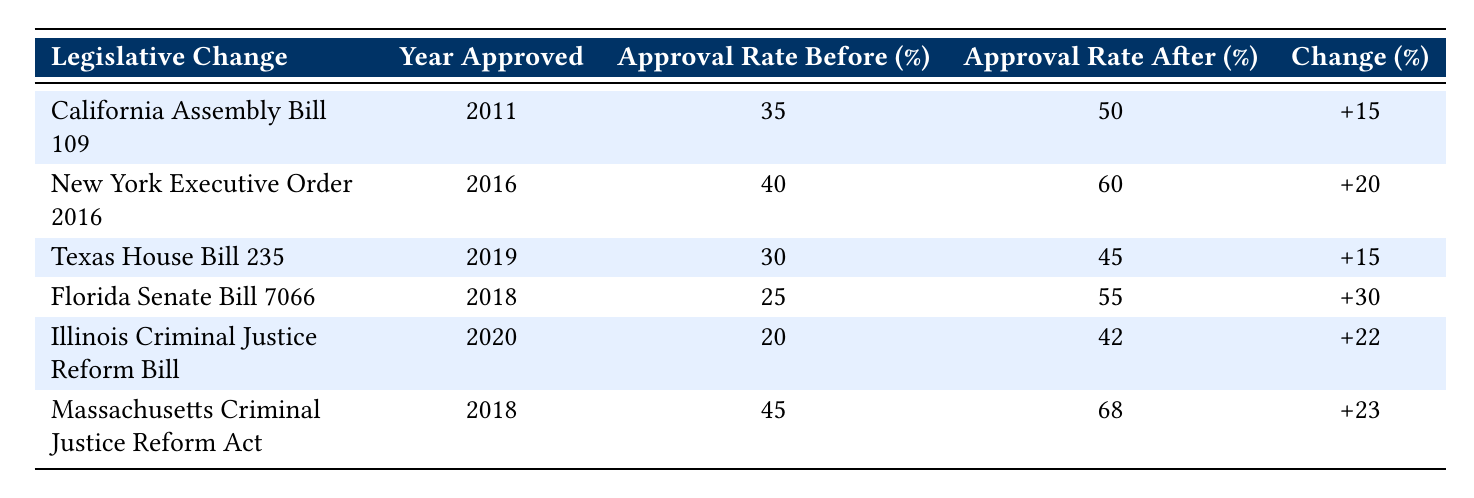What was the parole approval rate for Illinois Criminal Justice Reform Bill before the reform? The table lists the approval rate before the legislative change for Illinois Criminal Justice Reform Bill as 20%.
Answer: 20% What is the change in parole approval rate after New York Executive Order 2016? The table shows that the parole approval rate after the reform is 60% and before it was 40%, so the change is calculated by subtracting 40 from 60, resulting in a change of 20%.
Answer: +20% Which legislative change had the highest approval rate after its implementation? The table lists the approval rates after implementation, with Massachusetts Criminal Justice Reform Act at 68%, which is the highest compared to other listed changes.
Answer: Massachusetts Criminal Justice Reform Act How many legislative changes resulted in a parole approval rate increase of more than 20%? By examining the table, the changes greater than 20% are New York Executive Order 2016 (+20), Illinois Criminal Justice Reform Bill (+22), Florida Senate Bill 7066 (+30), and Massachusetts Criminal Justice Reform Act (+23), totaling four legislative changes.
Answer: 4 Is the parole approval rate after Illinois Criminal Justice Reform Bill higher than the rate before Texas House Bill 235? After Illinois Criminal Justice Reform Bill, the rate is 42%, while before Texas House Bill 235 the rate was 30%. Since 42 is greater than 30, the statement is true.
Answer: Yes What is the average parole approval rate before the legislative changes? To find the average, sum the approval rates before: 35 + 40 + 30 + 25 + 20 + 45 = 225. There are 6 data points (legislative changes), so the average is 225 / 6 = 37.5.
Answer: 37.5 What percentage increase is noted for Florida Senate Bill 7066? The table indicates that the approval rate increased from 25% to 55%, which results in a change of 30%. This is calculated by subtraction: 55 - 25 = 30.
Answer: +30 Which legislative change had the least increase in parole approval rate? Assessing the changes listed in the table, both California Assembly Bill 109 and Texas House Bill 235 had an increase of 15%, which is the least among all the listed legislative changes.
Answer: California Assembly Bill 109 and Texas House Bill 235 How can we conclude about the overall trend in parole approval rates following legislative changes? The data shows that all legislative changes resulted in an increase in parole approval rates; thus, the overall trend indicates improved outcomes for parole approvals post-legislation.
Answer: Overall trend is an increase 